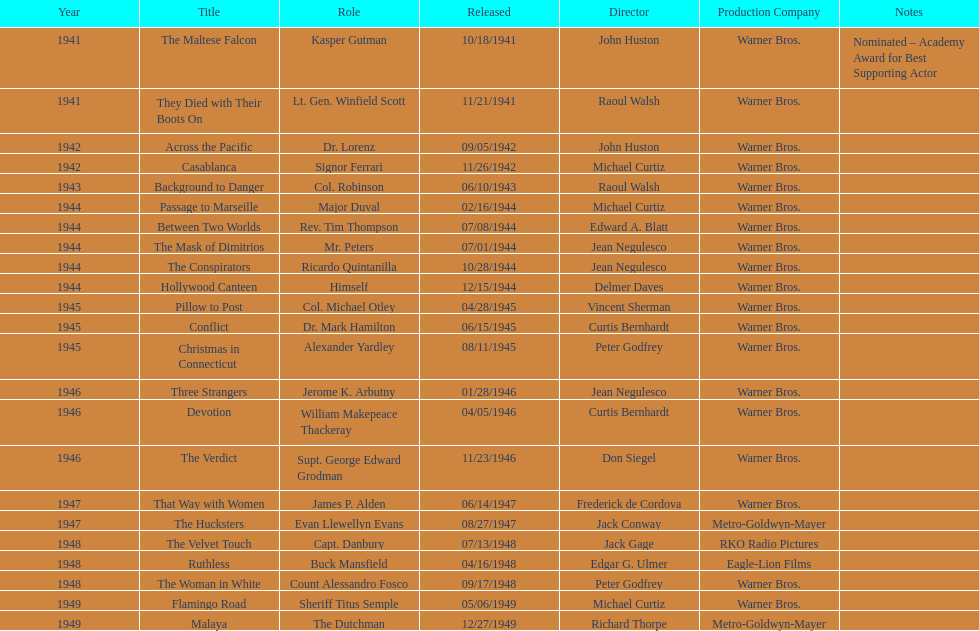Which movie did he get nominated for an oscar for? The Maltese Falcon. 